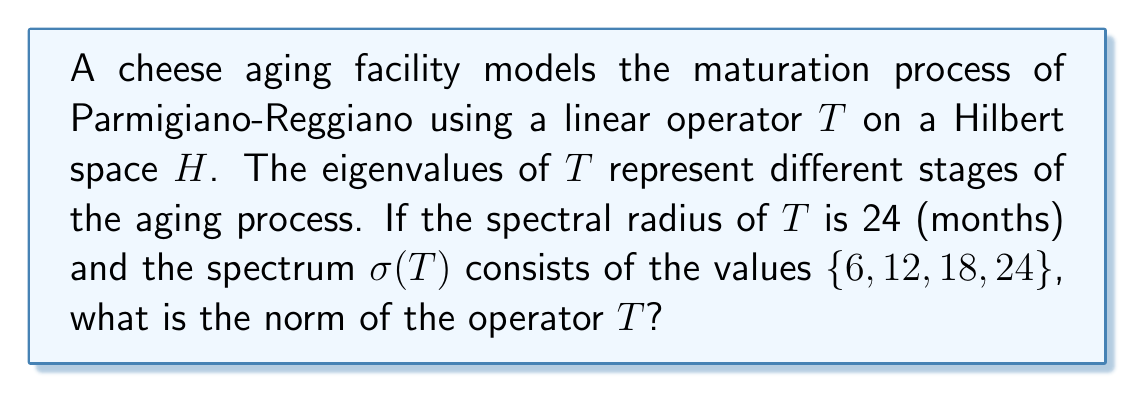Teach me how to tackle this problem. Let's approach this step-by-step:

1) In spectral theory, for a bounded linear operator $T$ on a Hilbert space $H$, we have:
   $$\|T\| \geq r(T)$$
   where $\|T\|$ is the operator norm and $r(T)$ is the spectral radius.

2) The spectral radius $r(T)$ is defined as:
   $$r(T) = \sup\{|\lambda| : \lambda \in \sigma(T)\}$$

3) Given information:
   - Spectral radius $r(T) = 24$
   - Spectrum $\sigma(T) = \{6, 12, 18, 24\}$

4) We can verify that the spectral radius is indeed the maximum absolute value in the spectrum:
   $$r(T) = \max\{|6|, |12|, |18|, |24|\} = 24$$

5) For normal operators (which include self-adjoint operators), we have the equality:
   $$\|T\| = r(T)$$

6) While we're not explicitly told that $T$ is normal, the fact that all eigenvalues are real and non-negative suggests that $T$ might be self-adjoint (and thus normal).

7) Assuming $T$ is indeed normal, we can conclude:
   $$\|T\| = r(T) = 24$$

Note: If $T$ is not normal, we can only say that $\|T\| \geq 24$. However, given the context of modeling a physical process (cheese aging), it's reasonable to assume $T$ is normal.
Answer: 24 